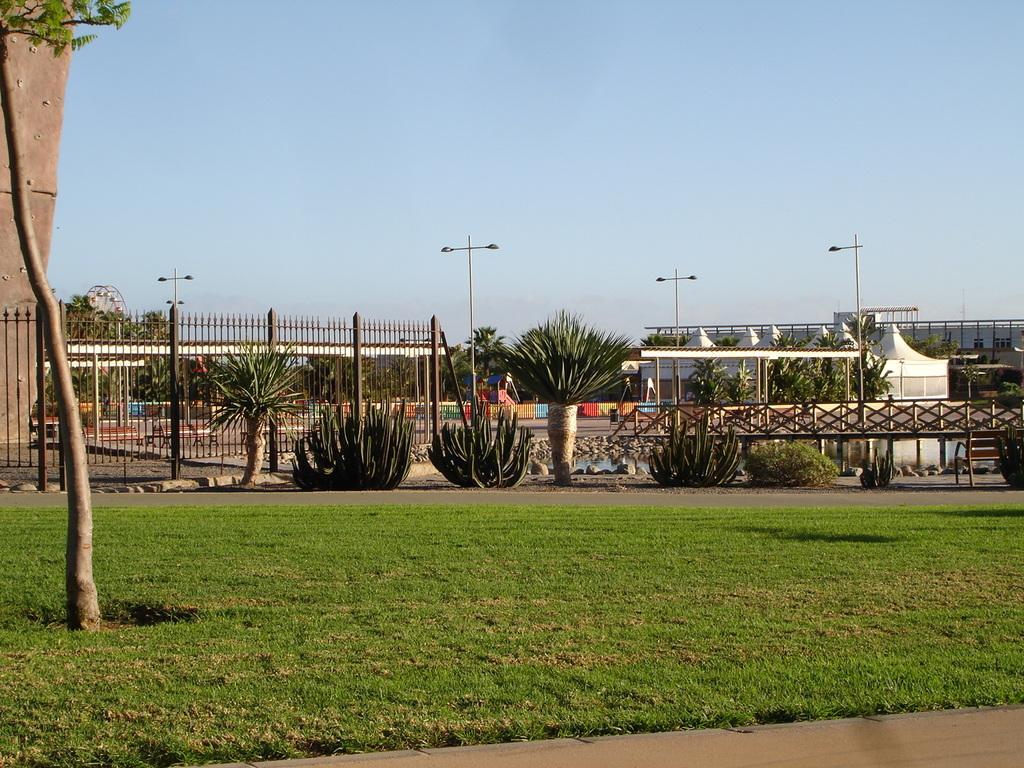In one or two sentences, can you explain what this image depicts? On the left side of the image we can see a tree. In the background, we can see the sky, buildings, fences, plants, grass, poles, one pillar type solid structure and a few other objects. 